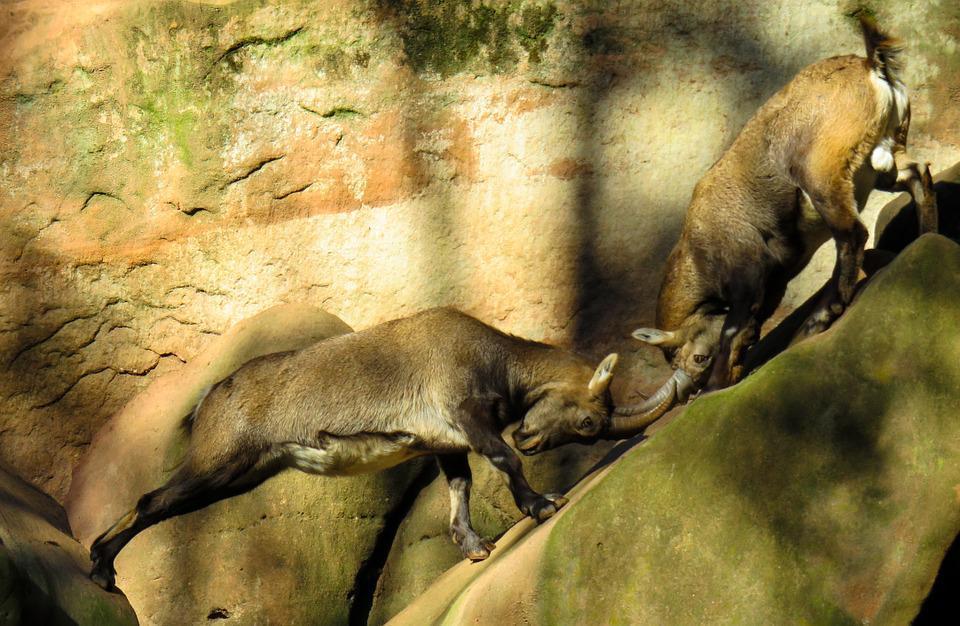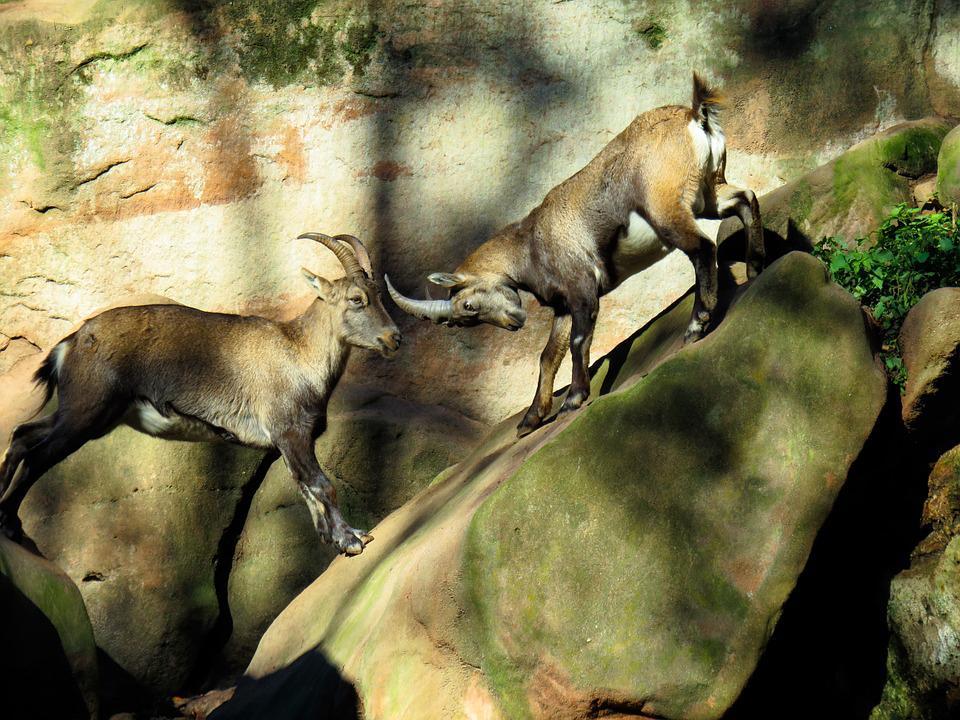The first image is the image on the left, the second image is the image on the right. Analyze the images presented: Is the assertion "Some of the animals are butting heads." valid? Answer yes or no. Yes. 